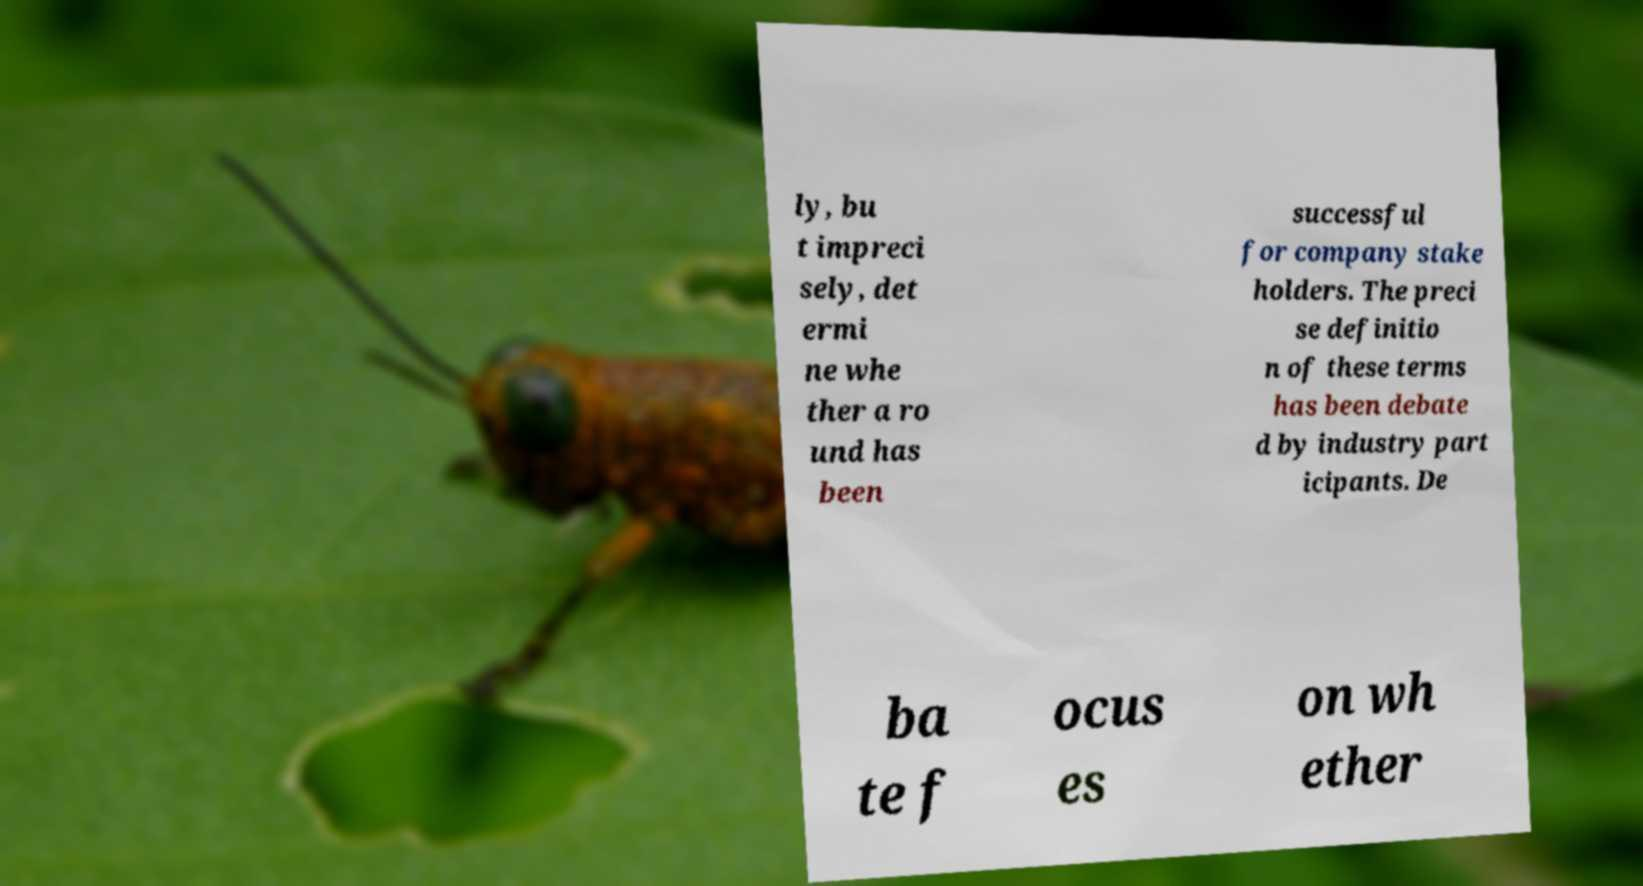Could you assist in decoding the text presented in this image and type it out clearly? ly, bu t impreci sely, det ermi ne whe ther a ro und has been successful for company stake holders. The preci se definitio n of these terms has been debate d by industry part icipants. De ba te f ocus es on wh ether 